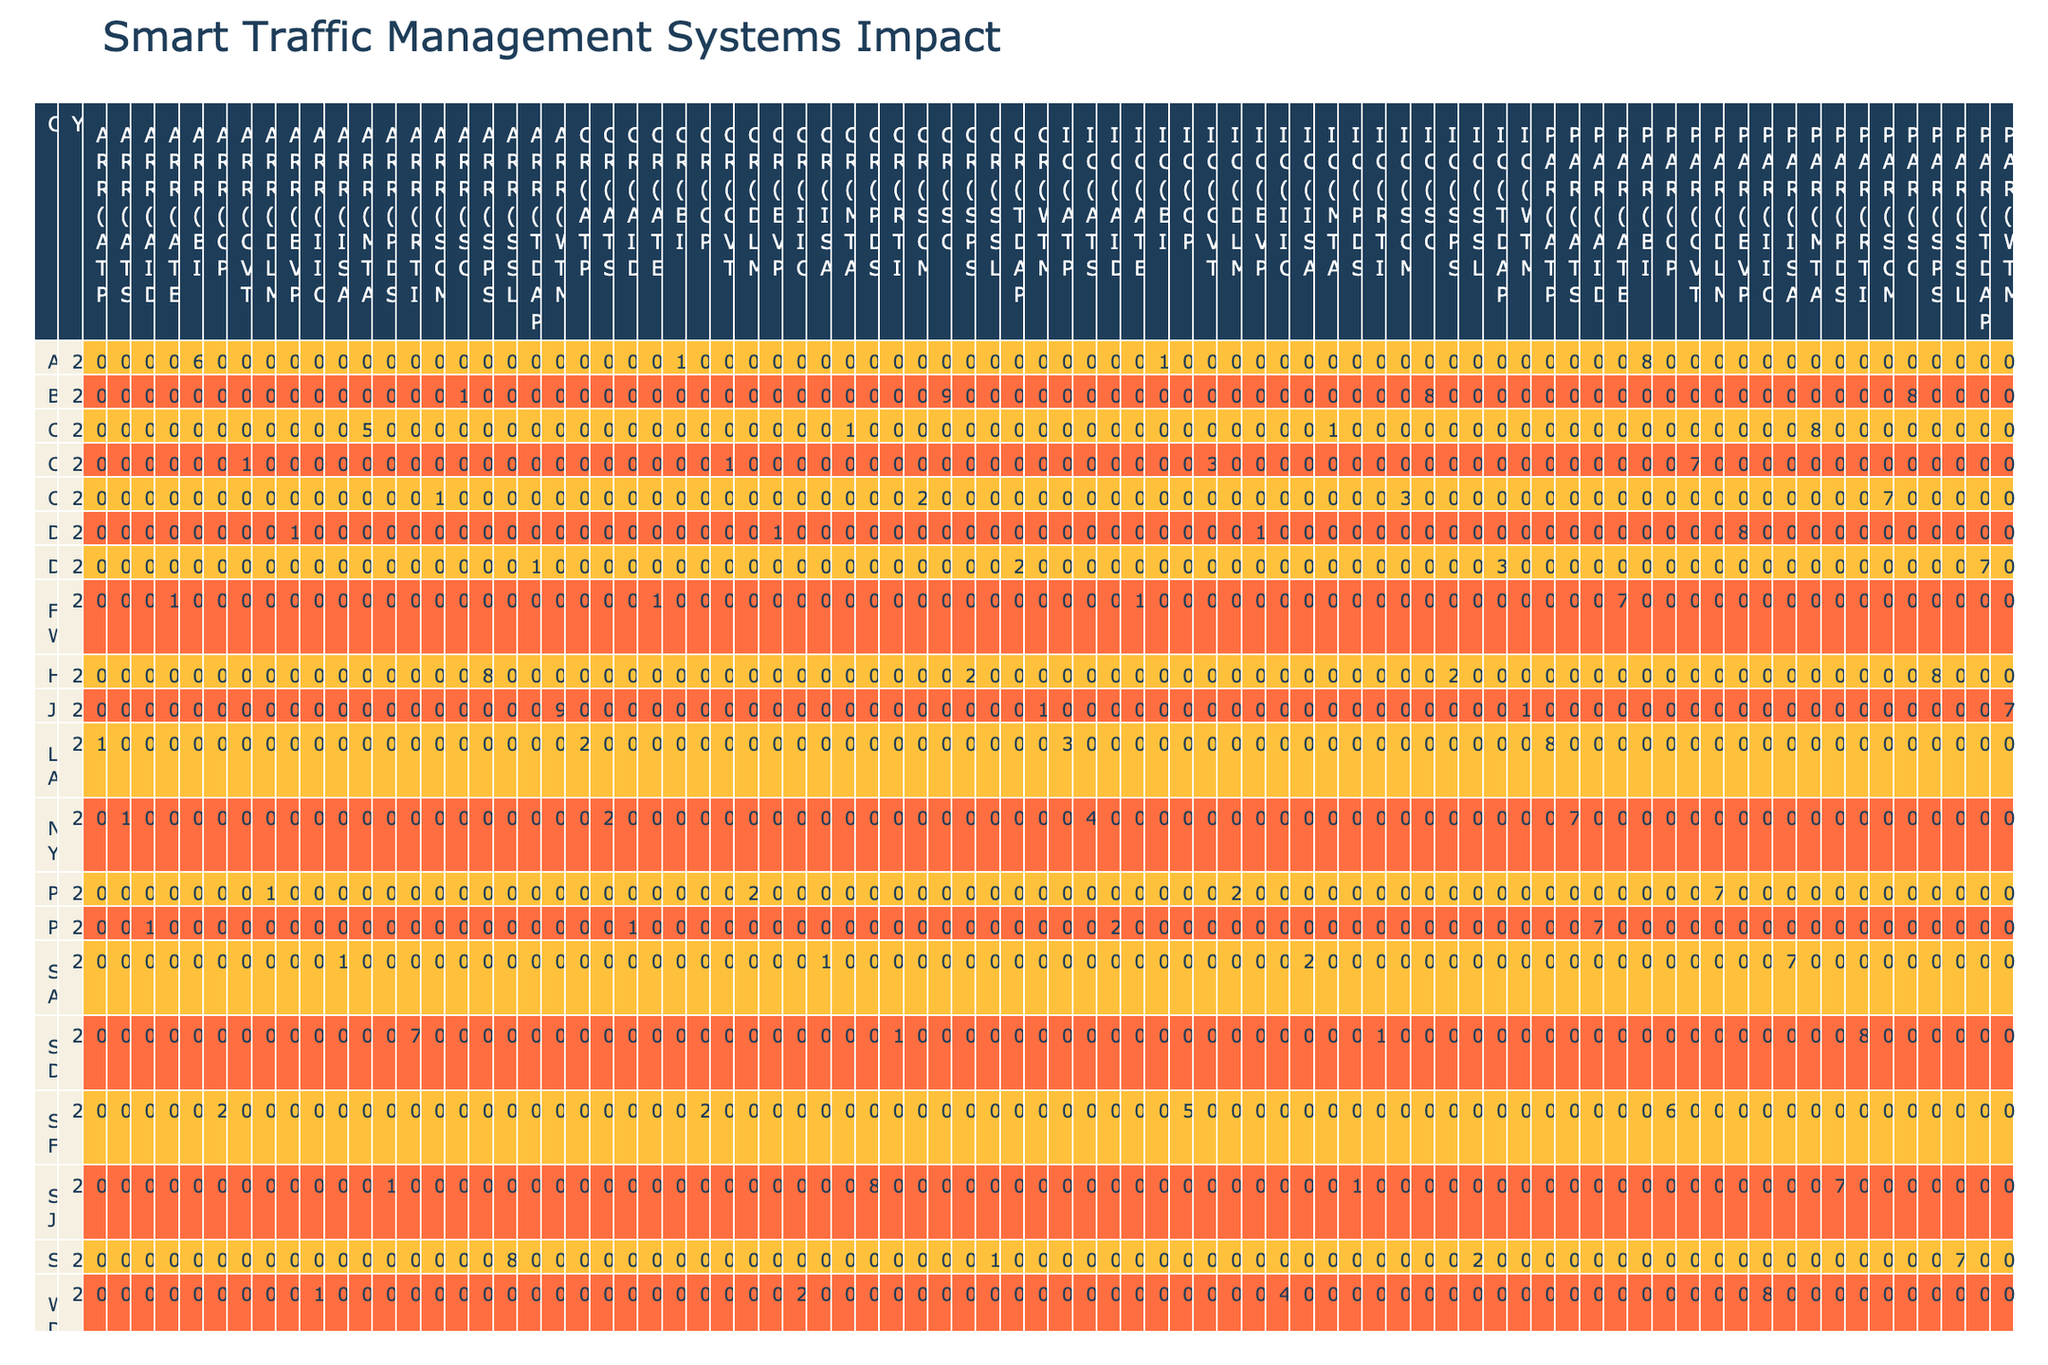What city had the highest accident rate reduction percentage? Looking at the "Accident Rate Reduction (%)" column, San Francisco in 2020 shows a rate of 20%, which is higher than any other city's listed values.
Answer: San Francisco Which smart system type had the lowest congestion reduction percentage? By reviewing the "Congestion Reduction (%)" column, we can see that the Bike-sharing Integration system used in Austin in 2022 had the lowest value at 14%.
Answer: Bike-sharing Integration What is the average implementation cost of the systems implemented in 2020? The implementation costs for 2020 are: New York ($45M), Phoenix ($22M), San Francisco ($50M), and Dallas ($15M). The total cost is 45 + 22 + 50 + 15 = 132, and there are 4 systems, so the average cost is 132 / 4 = 33.
Answer: 33 Did San Diego have a higher public approval rating than Chicago? Checking the "Public Approval Rating (%)" column, San Diego has a rating of 85%, while Chicago has 75%, therefore San Diego's rating is indeed higher.
Answer: Yes Which city with AI-powered technology had the greatest impact on congestion reduction? The only city with AI-powered technology is Los Angeles with an AI-powered Traffic Prediction system that had a congestion reduction of 25%. Since it's the only data point, it is also the greatest impact.
Answer: Los Angeles 